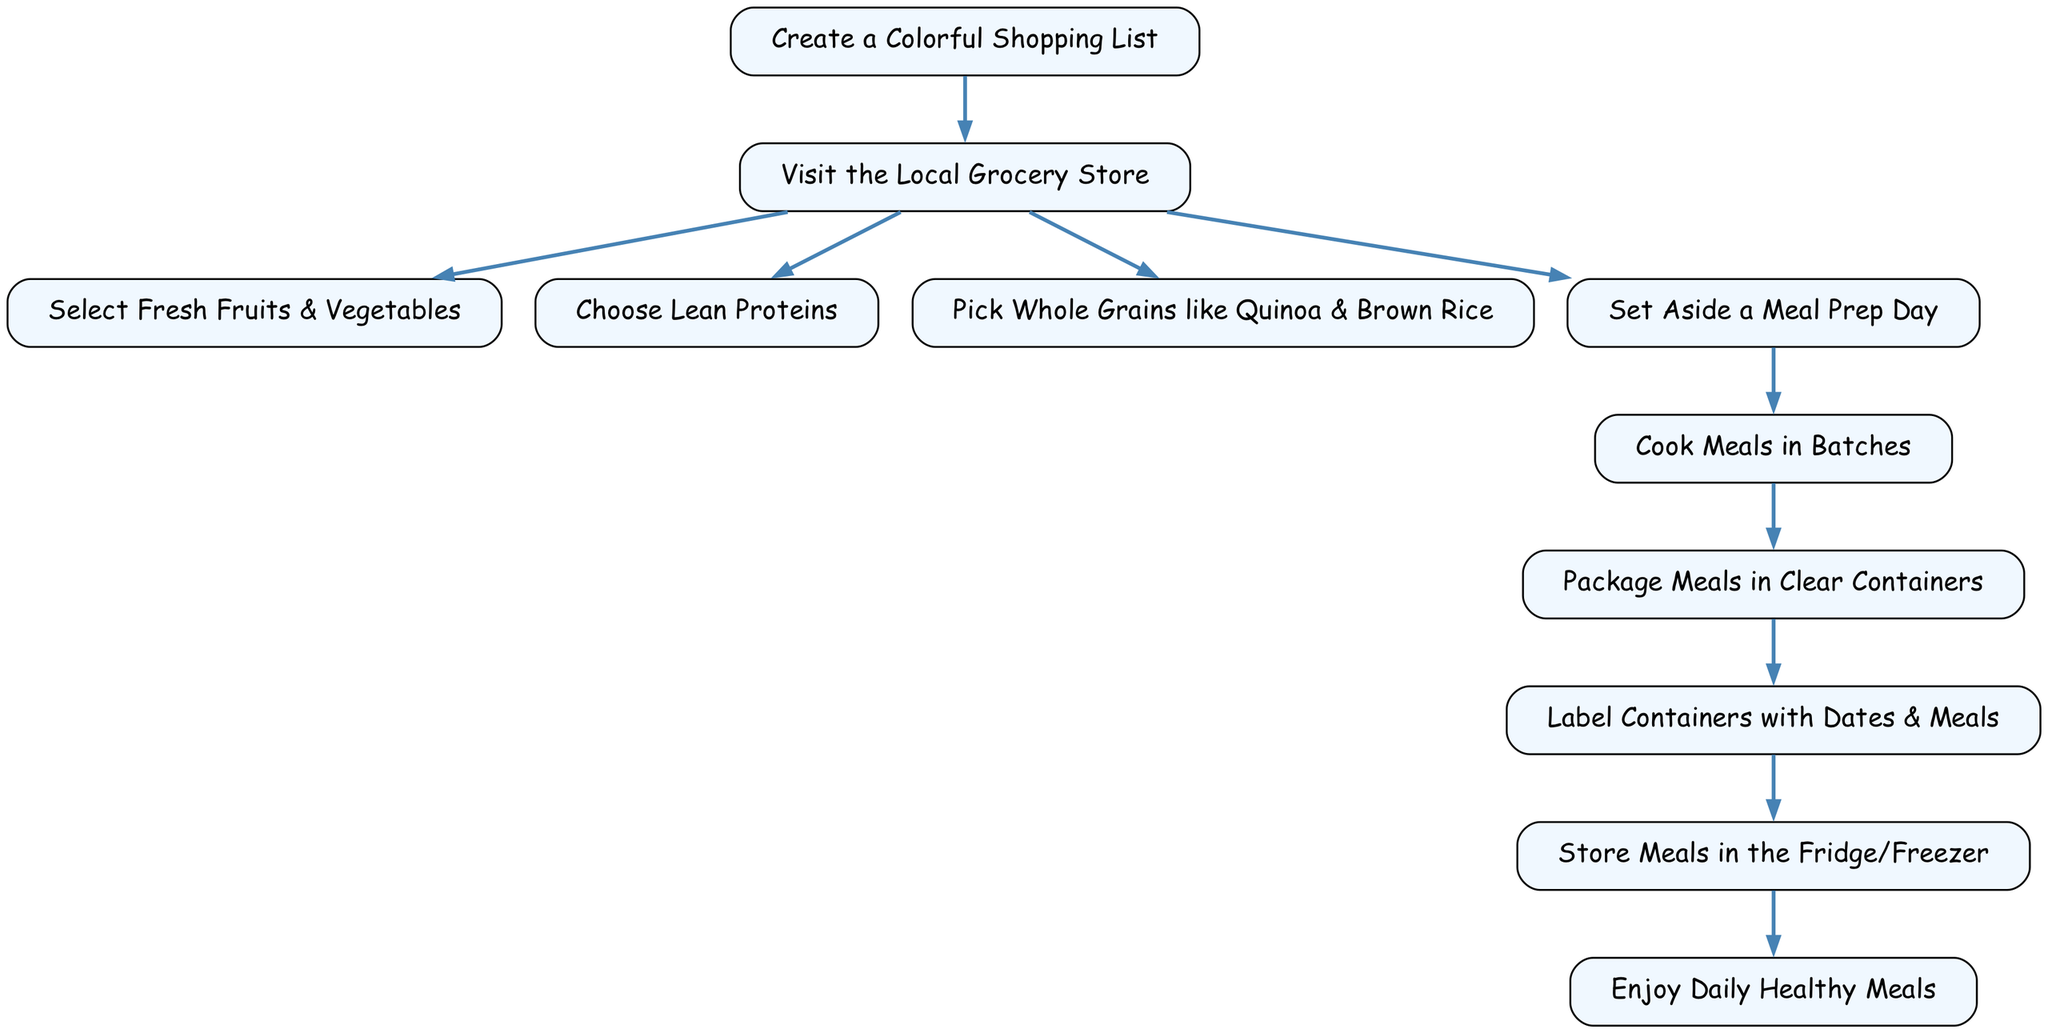What is the first step in the meal prep process? The diagram indicates that the first step is to "Create a Colorful Shopping List," as this is the starting point and precedes any further actions.
Answer: Create a Colorful Shopping List How many main activities are there after visiting the grocery store? After the "Visit the Local Grocery Store," there are three main activities: "Select Fresh Fruits & Vegetables," "Choose Lean Proteins," and "Pick Whole Grains like Quinoa & Brown Rice." Counting these gives us three activities.
Answer: Three What is the last step before enjoying daily meals? The last step before "Enjoy Daily Healthy Meals" is "Store Meals in the Fridge/Freezer," which is directly connected to the daily meals stage in the process.
Answer: Store Meals in the Fridge/Freezer What do you do after setting aside a meal prep day? After "Set Aside a Meal Prep Day," the next step is to "Cook Meals in Batches." This is the direct progression from the meal prep day.
Answer: Cook Meals in Batches How many total nodes are present in the diagram? The diagram contains a total of eleven nodes, each representing a distinct step or concept in the meal prep process. Each node is designed to illustrate a specific part of the flow.
Answer: Eleven Which step directly follows packaging meals? The step that directly follows "Package Meals in Clear Containers" is "Label Containers with Dates & Meals." This shows a clear sequence in the flow from packaging to labeling.
Answer: Label Containers with Dates & Meals Which two steps are connected directly by an edge? The steps "Cooking" and "Packaging" are directly connected by an edge, indicating that once cooking is done, the next action is packaging the meals.
Answer: Cooking and Packaging What type of ingredients should you choose at the grocery store? You should "Choose Lean Proteins" as one of the types of ingredients, which emphasizes the healthy aspect of meal prep highlighted in the diagram.
Answer: Choose Lean Proteins How does meal prep completion lead to daily enjoyment? Completing the meal prep process allows for meals to be "Stored Meals in the Fridge/Freezer," which enables having "Enjoy Daily Healthy Meals." This progression emphasizes the benefit of meal prep.
Answer: Enjoy Daily Healthy Meals 